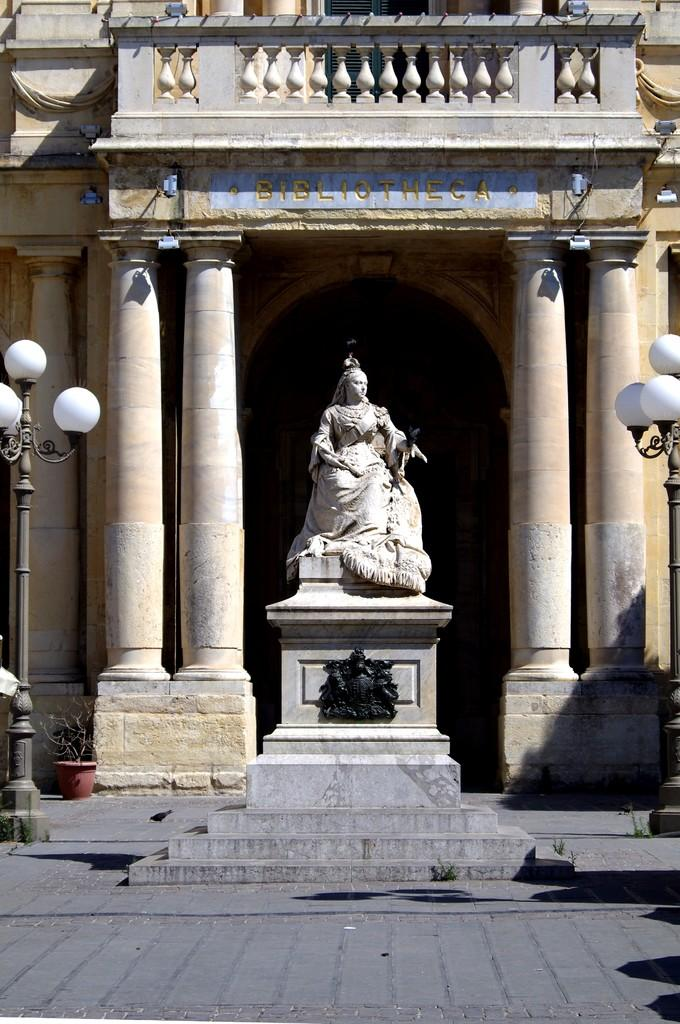What is the main subject in the center of the image? There is a statue in the center of the image. What can be seen in the background of the image? There is a building in the background of the image. What type of structures are present in the image? There are light poles in the image. What type of ink is used to write on the statue in the image? There is no ink or writing present on the statue in the image. 